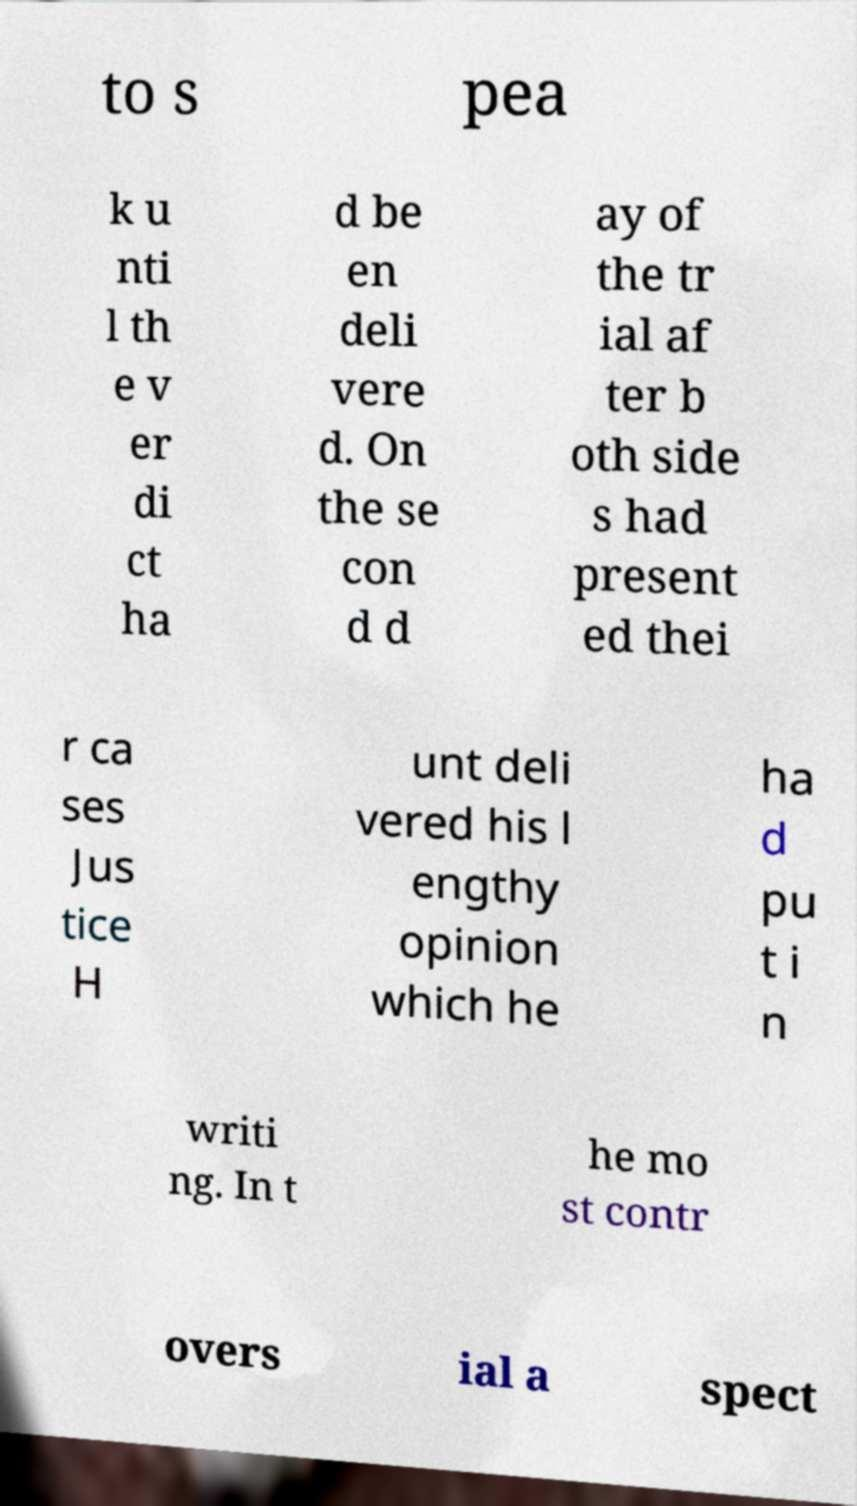Can you accurately transcribe the text from the provided image for me? to s pea k u nti l th e v er di ct ha d be en deli vere d. On the se con d d ay of the tr ial af ter b oth side s had present ed thei r ca ses Jus tice H unt deli vered his l engthy opinion which he ha d pu t i n writi ng. In t he mo st contr overs ial a spect 